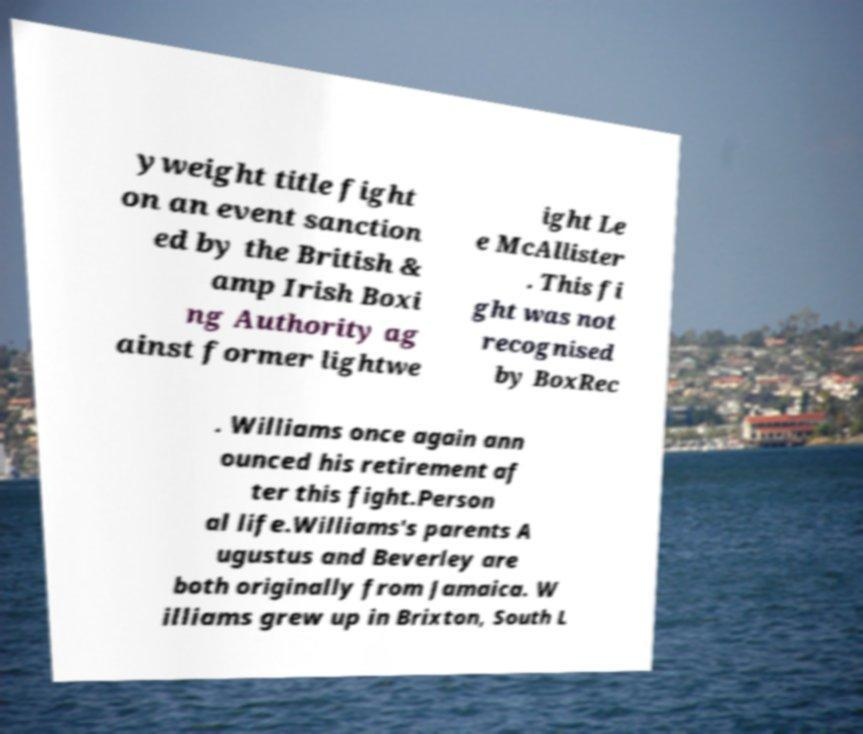For documentation purposes, I need the text within this image transcribed. Could you provide that? yweight title fight on an event sanction ed by the British & amp Irish Boxi ng Authority ag ainst former lightwe ight Le e McAllister . This fi ght was not recognised by BoxRec . Williams once again ann ounced his retirement af ter this fight.Person al life.Williams's parents A ugustus and Beverley are both originally from Jamaica. W illiams grew up in Brixton, South L 